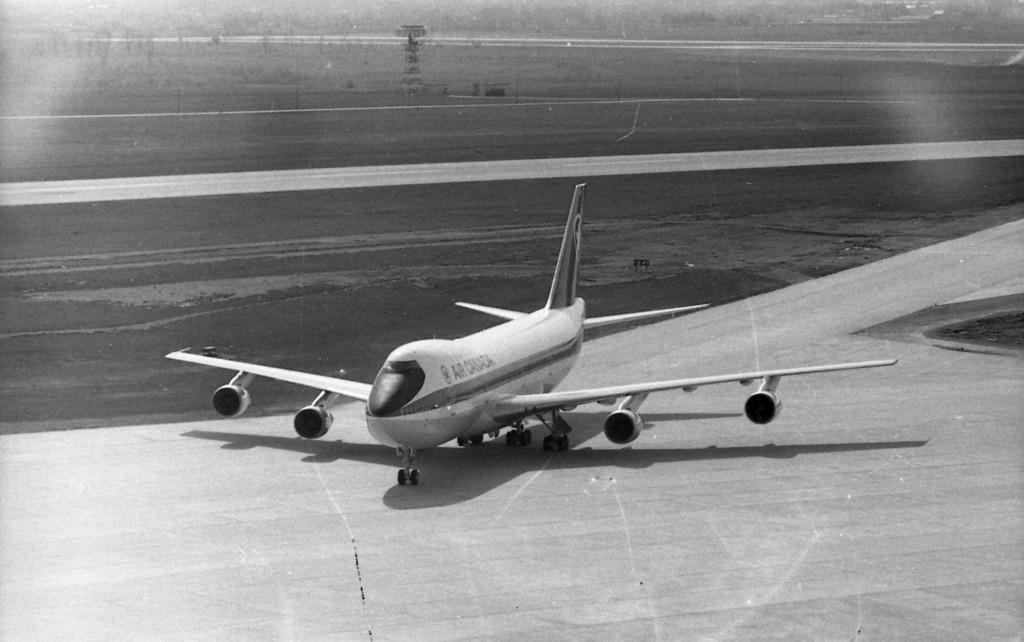<image>
Present a compact description of the photo's key features. An Air Canada plane is on the runway. 